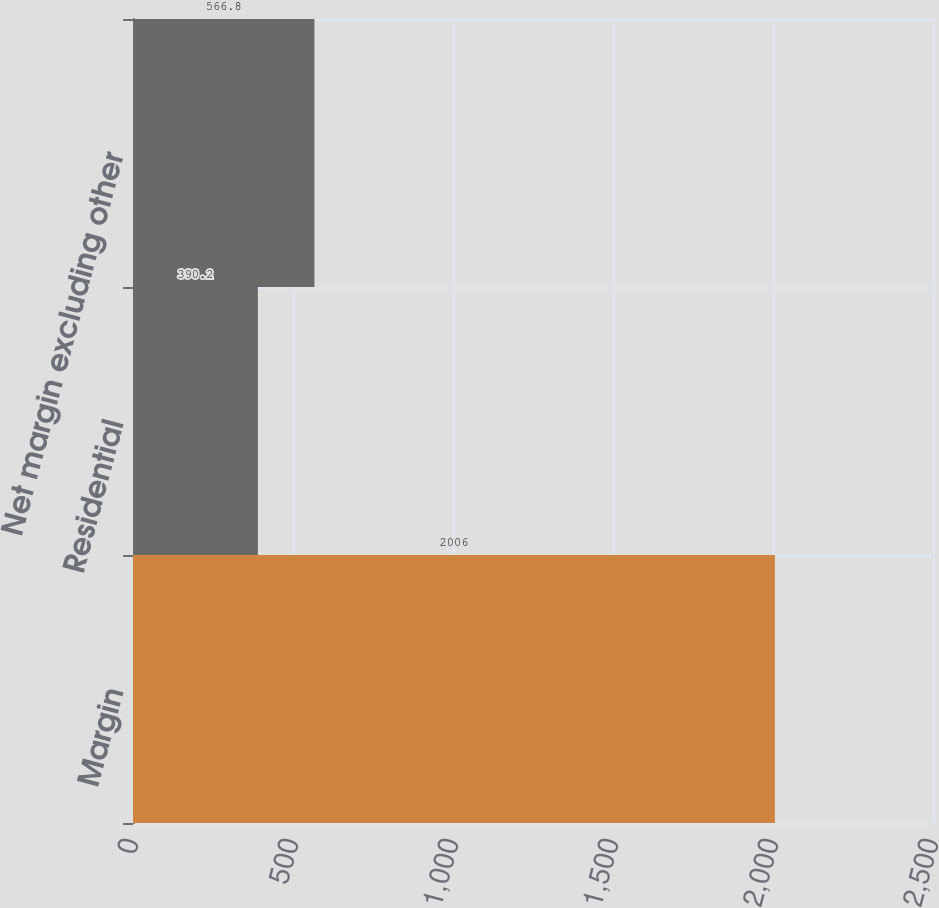<chart> <loc_0><loc_0><loc_500><loc_500><bar_chart><fcel>Margin<fcel>Residential<fcel>Net margin excluding other<nl><fcel>2006<fcel>390.2<fcel>566.8<nl></chart> 